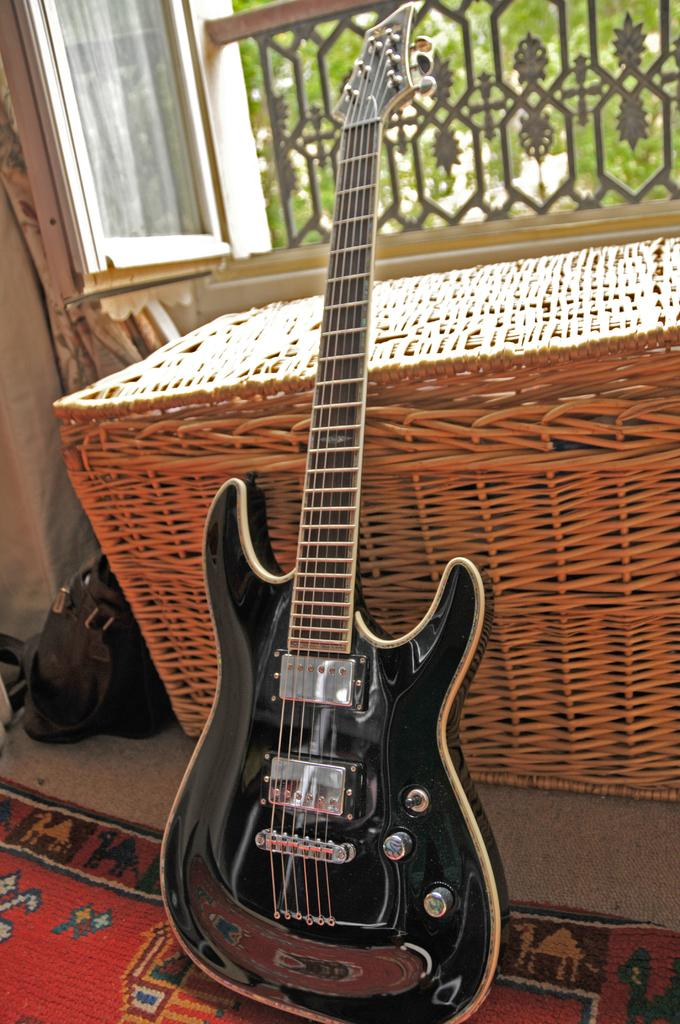What musical instrument is present in the image? There is a guitar in the image. What can be seen on the right side of the image? There is a window on the right side of the image. How many eggs are visible on the guitar in the image? There are no eggs present on the guitar in the image. What type of tool is being used by the son in the image? There is no son or tool present in the image; it only features a guitar and a window. 